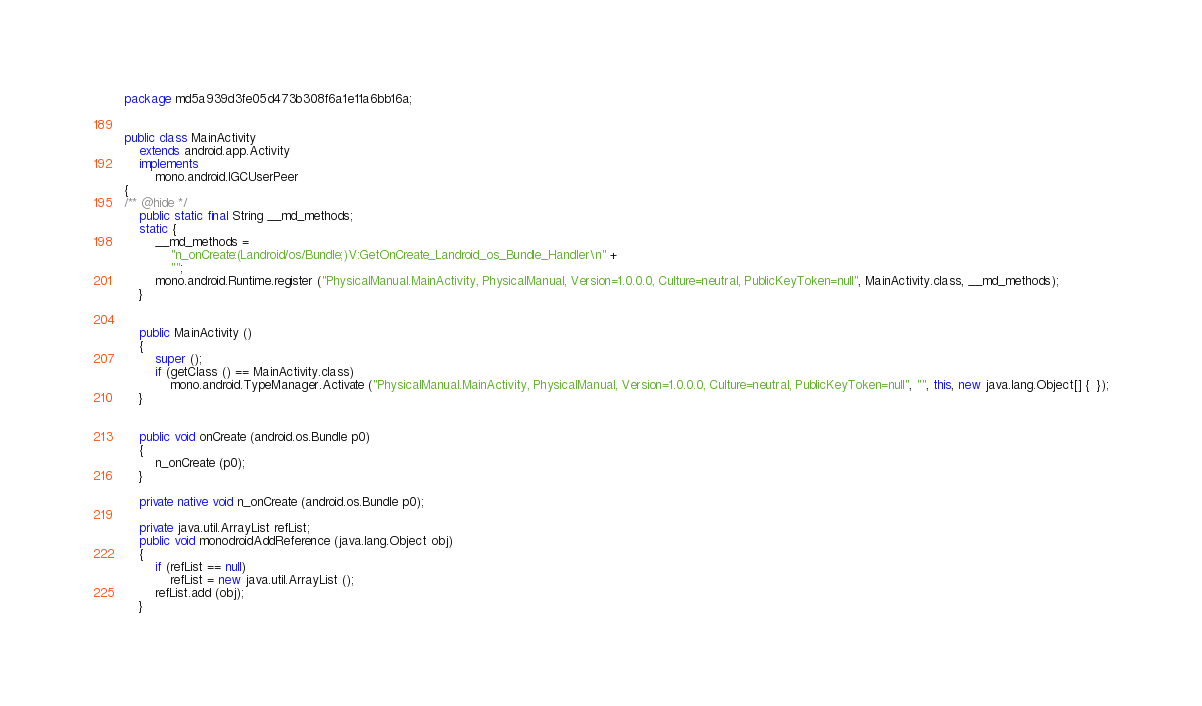Convert code to text. <code><loc_0><loc_0><loc_500><loc_500><_Java_>package md5a939d3fe05d473b308f6a1e11a6bb16a;


public class MainActivity
	extends android.app.Activity
	implements
		mono.android.IGCUserPeer
{
/** @hide */
	public static final String __md_methods;
	static {
		__md_methods = 
			"n_onCreate:(Landroid/os/Bundle;)V:GetOnCreate_Landroid_os_Bundle_Handler\n" +
			"";
		mono.android.Runtime.register ("PhysicalManual.MainActivity, PhysicalManual, Version=1.0.0.0, Culture=neutral, PublicKeyToken=null", MainActivity.class, __md_methods);
	}


	public MainActivity ()
	{
		super ();
		if (getClass () == MainActivity.class)
			mono.android.TypeManager.Activate ("PhysicalManual.MainActivity, PhysicalManual, Version=1.0.0.0, Culture=neutral, PublicKeyToken=null", "", this, new java.lang.Object[] {  });
	}


	public void onCreate (android.os.Bundle p0)
	{
		n_onCreate (p0);
	}

	private native void n_onCreate (android.os.Bundle p0);

	private java.util.ArrayList refList;
	public void monodroidAddReference (java.lang.Object obj)
	{
		if (refList == null)
			refList = new java.util.ArrayList ();
		refList.add (obj);
	}
</code> 